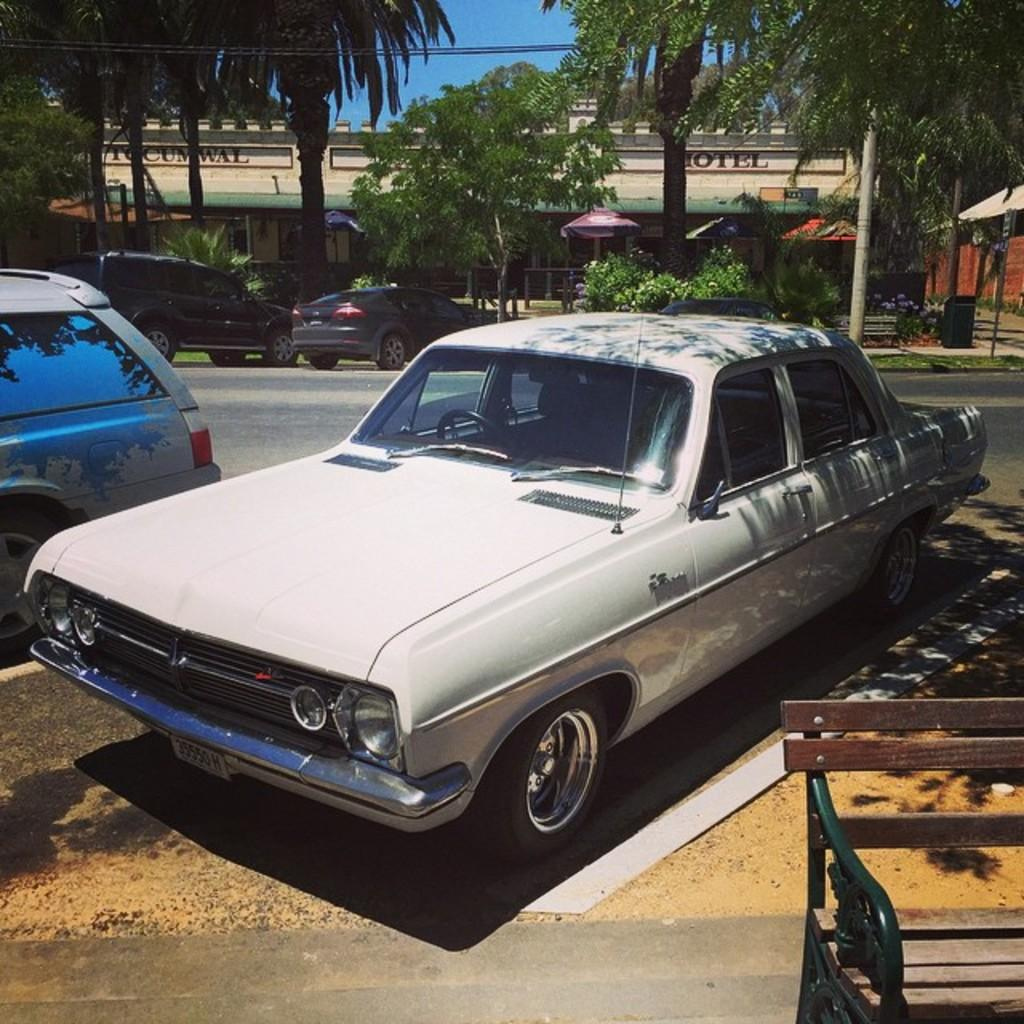What is the main subject of the image? There is a car in the image. What is located in front of the car? There is a wooden bench in front of the car. What is visible behind the wooden bench? There is a road behind the wooden bench. What can be seen behind the road? There are trees visible behind the road. What is located behind the trees? There is a building behind the trees. What scientific experiment is being conducted on the car in the image? There is no scientific experiment being conducted on the car in the image. How often does the car need to be washed according to the rule in the image? There is no rule regarding car washing in the image. 